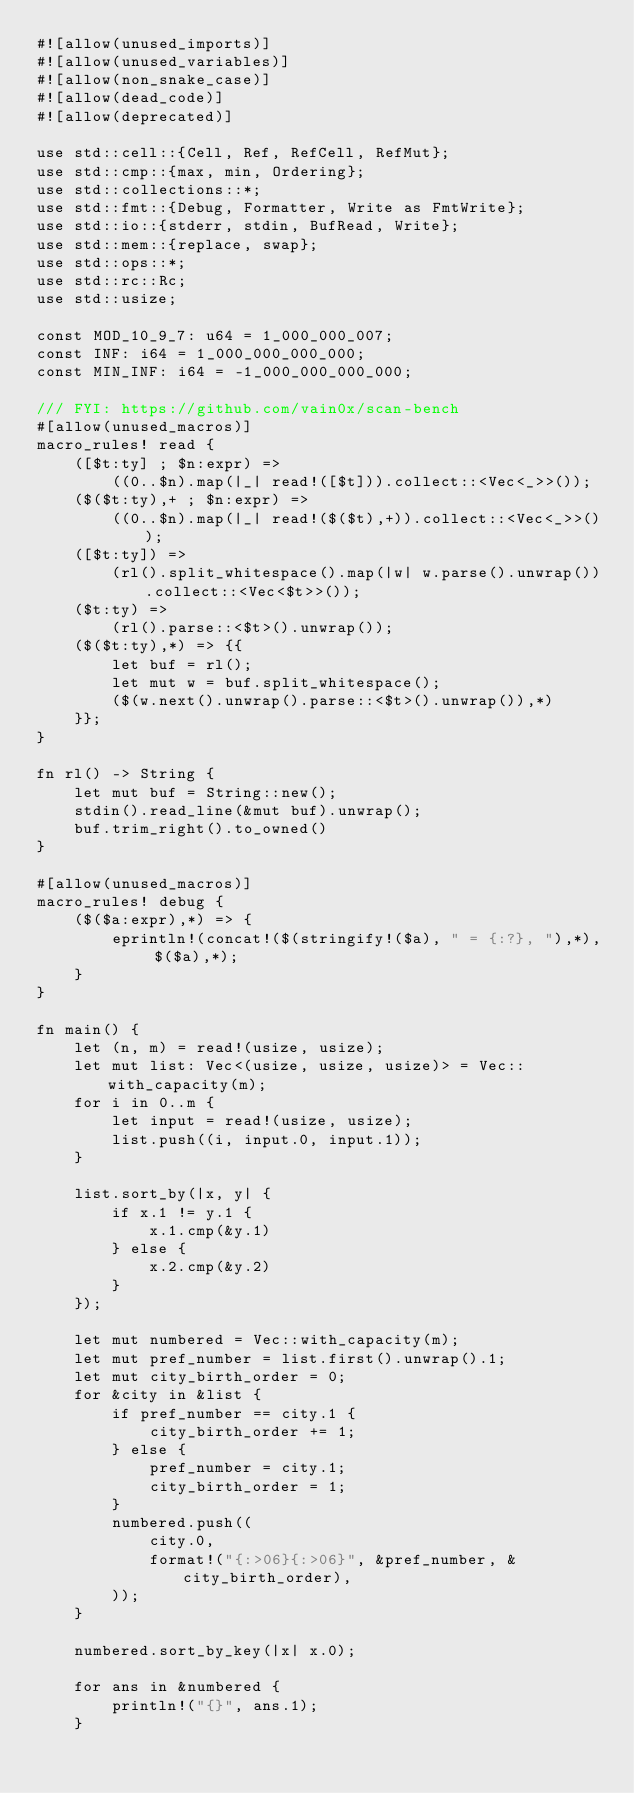<code> <loc_0><loc_0><loc_500><loc_500><_Rust_>#![allow(unused_imports)]
#![allow(unused_variables)]
#![allow(non_snake_case)]
#![allow(dead_code)]
#![allow(deprecated)]

use std::cell::{Cell, Ref, RefCell, RefMut};
use std::cmp::{max, min, Ordering};
use std::collections::*;
use std::fmt::{Debug, Formatter, Write as FmtWrite};
use std::io::{stderr, stdin, BufRead, Write};
use std::mem::{replace, swap};
use std::ops::*;
use std::rc::Rc;
use std::usize;

const MOD_10_9_7: u64 = 1_000_000_007;
const INF: i64 = 1_000_000_000_000;
const MIN_INF: i64 = -1_000_000_000_000;

/// FYI: https://github.com/vain0x/scan-bench
#[allow(unused_macros)]
macro_rules! read {
    ([$t:ty] ; $n:expr) =>
        ((0..$n).map(|_| read!([$t])).collect::<Vec<_>>());
    ($($t:ty),+ ; $n:expr) =>
        ((0..$n).map(|_| read!($($t),+)).collect::<Vec<_>>());
    ([$t:ty]) =>
        (rl().split_whitespace().map(|w| w.parse().unwrap()).collect::<Vec<$t>>());
    ($t:ty) =>
        (rl().parse::<$t>().unwrap());
    ($($t:ty),*) => {{
        let buf = rl();
        let mut w = buf.split_whitespace();
        ($(w.next().unwrap().parse::<$t>().unwrap()),*)
    }};
}

fn rl() -> String {
    let mut buf = String::new();
    stdin().read_line(&mut buf).unwrap();
    buf.trim_right().to_owned()
}

#[allow(unused_macros)]
macro_rules! debug {
    ($($a:expr),*) => {
        eprintln!(concat!($(stringify!($a), " = {:?}, "),*), $($a),*);
    }
}

fn main() {
    let (n, m) = read!(usize, usize);
    let mut list: Vec<(usize, usize, usize)> = Vec::with_capacity(m);
    for i in 0..m {
        let input = read!(usize, usize);
        list.push((i, input.0, input.1));
    }

    list.sort_by(|x, y| {
        if x.1 != y.1 {
            x.1.cmp(&y.1)
        } else {
            x.2.cmp(&y.2)
        }
    });

    let mut numbered = Vec::with_capacity(m);
    let mut pref_number = list.first().unwrap().1;
    let mut city_birth_order = 0;
    for &city in &list {
        if pref_number == city.1 {
            city_birth_order += 1;
        } else {
            pref_number = city.1;
            city_birth_order = 1;
        }
        numbered.push((
            city.0,
            format!("{:>06}{:>06}", &pref_number, &city_birth_order),
        ));
    }

    numbered.sort_by_key(|x| x.0);

    for ans in &numbered {
        println!("{}", ans.1);
    }
</code> 